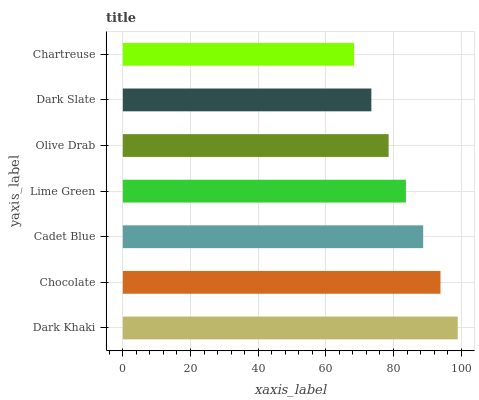Is Chartreuse the minimum?
Answer yes or no. Yes. Is Dark Khaki the maximum?
Answer yes or no. Yes. Is Chocolate the minimum?
Answer yes or no. No. Is Chocolate the maximum?
Answer yes or no. No. Is Dark Khaki greater than Chocolate?
Answer yes or no. Yes. Is Chocolate less than Dark Khaki?
Answer yes or no. Yes. Is Chocolate greater than Dark Khaki?
Answer yes or no. No. Is Dark Khaki less than Chocolate?
Answer yes or no. No. Is Lime Green the high median?
Answer yes or no. Yes. Is Lime Green the low median?
Answer yes or no. Yes. Is Dark Khaki the high median?
Answer yes or no. No. Is Dark Khaki the low median?
Answer yes or no. No. 